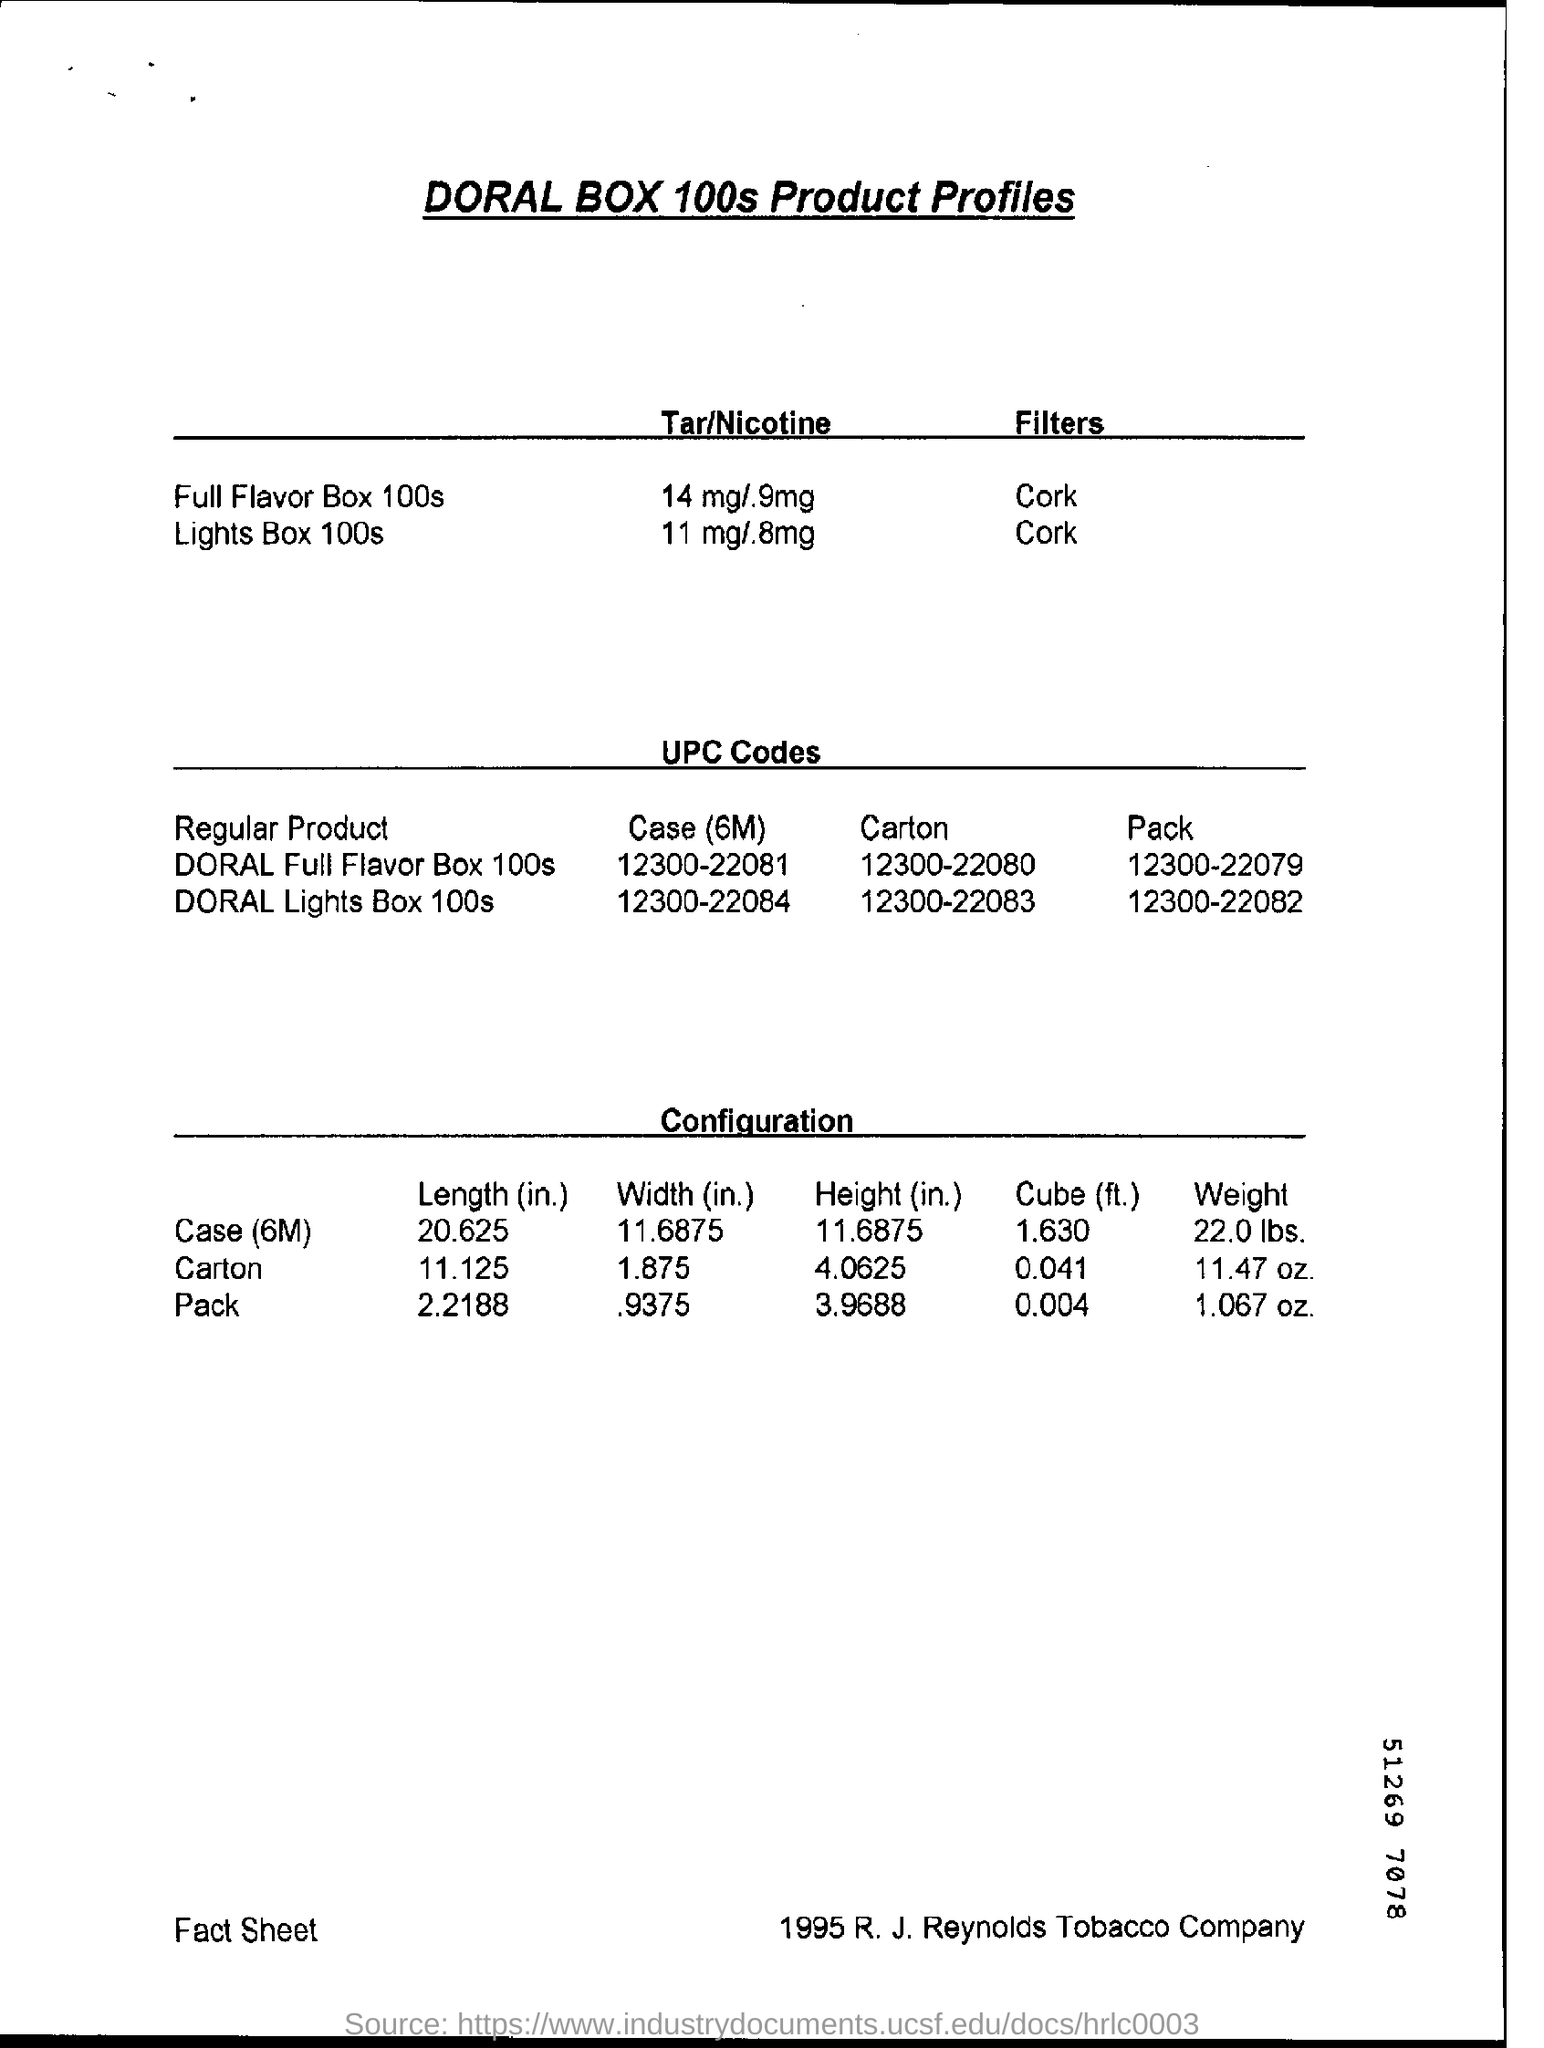Indicate a few pertinent items in this graphic. The weight of a pack is 1.067 ounces. The Lights Box 100s contains 11 milligrams of tar and .8 milligrams of nicotine per cigarette. The UPC code of the DORAL Full Flavour Box 100s Carton is 12300-22080. 